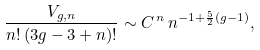Convert formula to latex. <formula><loc_0><loc_0><loc_500><loc_500>\frac { V _ { g , n } } { n ! \, ( 3 g - 3 + n ) ! } \sim C ^ { \, n } \, n ^ { - 1 + \frac { 5 } { 2 } ( g - 1 ) } ,</formula> 